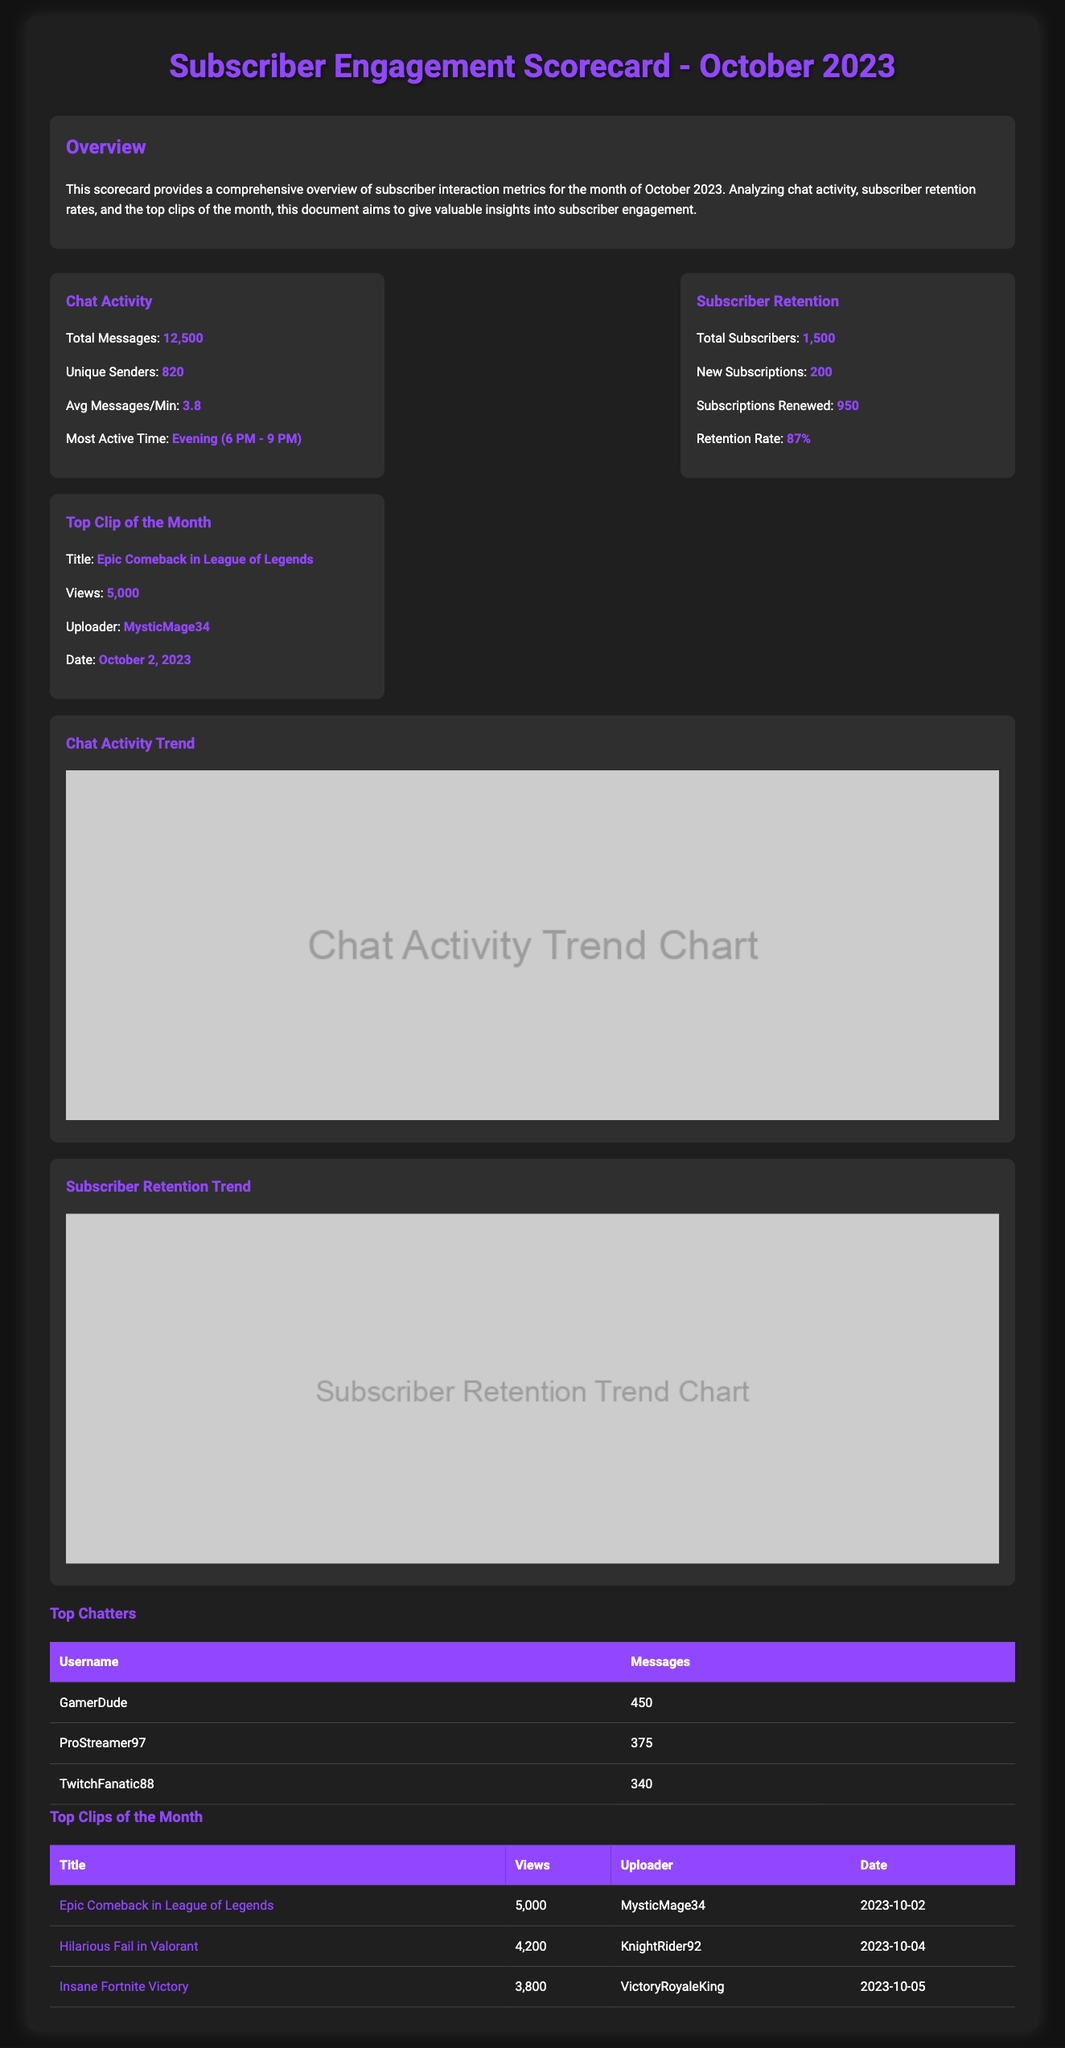What is the total number of messages sent? The total messages sent is presented in the Chat Activity section, which states there were 12,500 messages.
Answer: 12,500 What is the average messages per minute? The average messages per minute is indicated in the Chat Activity section as 3.8.
Answer: 3.8 What is the subscriber retention rate? The retention rate can be found in the Subscriber Retention section, which reports it as 87%.
Answer: 87% Who is the uploader of the top clip of the month? The uploader's name is mentioned in the Top Clip of the Month, which is MysticMage34.
Answer: MysticMage34 During what time was the chat most active? The most active chat time is specified in the Chat Activity section as Evening (6 PM - 9 PM).
Answer: Evening (6 PM - 9 PM) How many new subscriptions were there in October 2023? The total number of new subscriptions is found in the Subscriber Retention section, which reports 200 new subscriptions.
Answer: 200 What date was the top clip of the month uploaded? The upload date for the top clip is listed as October 2, 2023.
Answer: October 2, 2023 What is the title of the top clip? The title of the top clip is highlighted in the Top Clip of the Month section as Epic Comeback in League of Legends.
Answer: Epic Comeback in League of Legends How many unique senders participated in the chat? The number of unique senders is detailed in the Chat Activity section, reporting 820 unique senders.
Answer: 820 